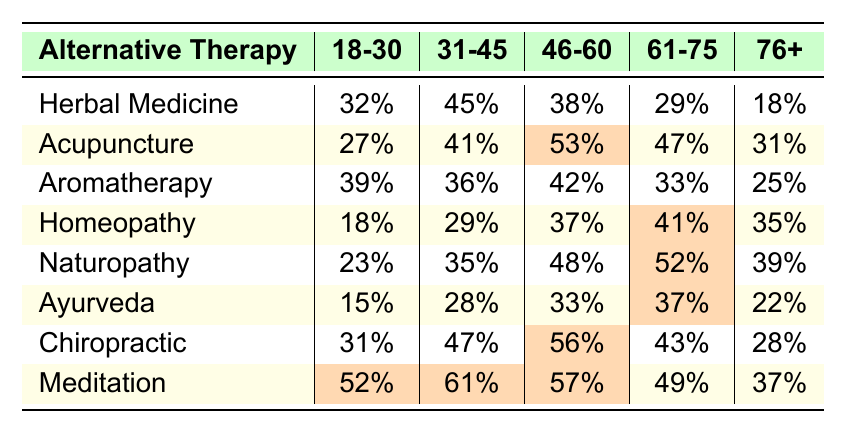What is the percentage of people aged 18-30 who use Aromatherapy? From the table, under the age group 18-30, the percentage for Aromatherapy is listed as 39%.
Answer: 39% Which alternative therapy has the highest usage percentage among the 31-45 age group? In the table, the therapy with the highest percentage under the 31-45 age group is Chiropractic at 47%.
Answer: Chiropractic What is the average usage percentage of Homeopathy and Naturopathy for the 46-60 age group? For Homeopathy, the percentage is 37%, and for Naturopathy, it is 48%. The average is (37 + 48) / 2 = 42.5%.
Answer: 42.5% Is the percentage of people aged 61-75 who use Acupuncture greater than 30%? The table shows that the percentage for Acupuncture in the 61-75 age group is 47%, which is indeed greater than 30%.
Answer: Yes What is the difference in usage percentage between Meditation and Herbal Medicine for age group 18-30? The percentage for Meditation in the 18-30 age group is 52%, while Herbal Medicine is 32%. The difference is 52 - 32 = 20%.
Answer: 20% Which alternative therapies have a usage percentage of 50% or more among those aged 76 and older? In the table, Naturopathy (52%) and Homeopathy (51%) are identified as the therapies with usage percentages of 50% or more in the 76+ age group.
Answer: Naturopathy and Homeopathy What percentage of individuals aged 46-60 prefer Chiropractic over Acupuncture? Chiropractic usage is 56% and Acupuncture is 53%. Subtracting gives 56 - 53 = 3%, indicating more prefer Chiropractic by that margin.
Answer: 3% If we sum the percentages for Herbal Medicine across all age groups, what is the total? The percentages for Herbal Medicine across all age groups are 32%, 45%, 38%, 29%, and 18%. The total is 32 + 45 + 38 + 29 + 18 = 162%.
Answer: 162% Is the average percentage of Aromatherapy users higher in the 31-45 age group compared to the 61-75 age group? Aromatherapy for 31-45 is 36% and for 61-75 is 33%. Since 36% is greater than 33%, the average usage in the 31-45 age group is higher.
Answer: Yes What is the least used alternative therapy among individuals aged 18-30? From the table, Ayurveda shows the lowest percentage at 15% for the age group 18-30.
Answer: Ayurveda 